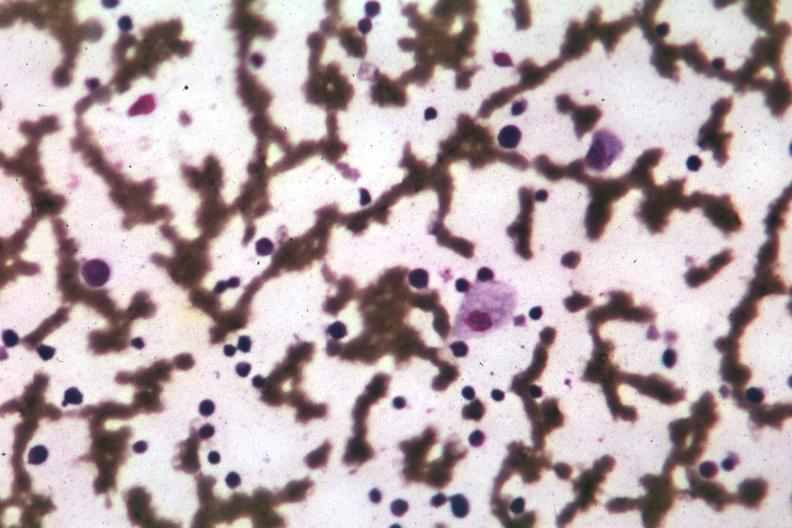s bone marrow present?
Answer the question using a single word or phrase. Yes 